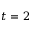<formula> <loc_0><loc_0><loc_500><loc_500>t = 2</formula> 